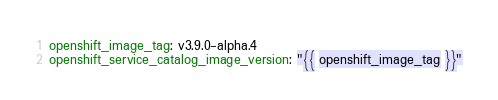Convert code to text. <code><loc_0><loc_0><loc_500><loc_500><_YAML_>openshift_image_tag: v3.9.0-alpha.4
openshift_service_catalog_image_version: "{{ openshift_image_tag }}"
</code> 